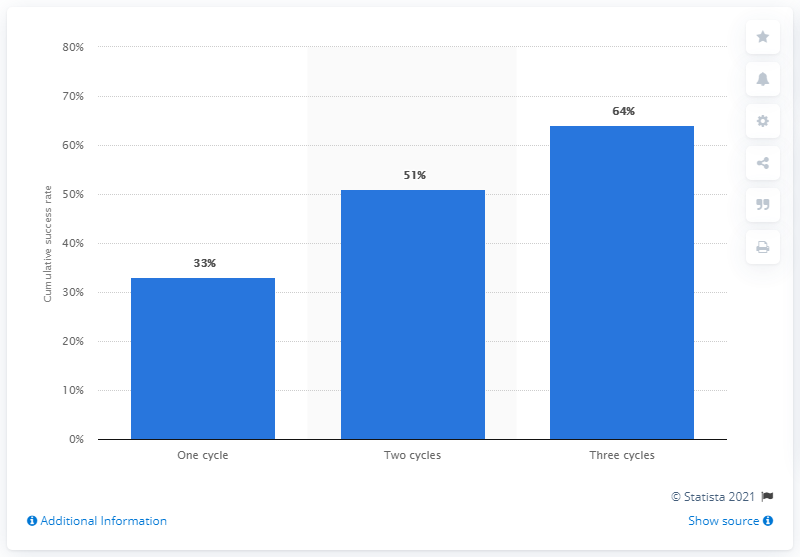Point out several critical features in this image. The cumulative success rate of in-vitro fertilization treatments in the United States as of 2015 was 51%. 